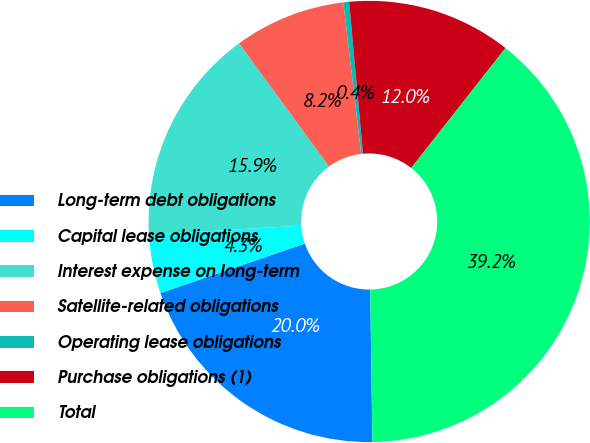Convert chart to OTSL. <chart><loc_0><loc_0><loc_500><loc_500><pie_chart><fcel>Long-term debt obligations<fcel>Capital lease obligations<fcel>Interest expense on long-term<fcel>Satellite-related obligations<fcel>Operating lease obligations<fcel>Purchase obligations (1)<fcel>Total<nl><fcel>19.98%<fcel>4.3%<fcel>15.92%<fcel>8.17%<fcel>0.42%<fcel>12.05%<fcel>39.17%<nl></chart> 